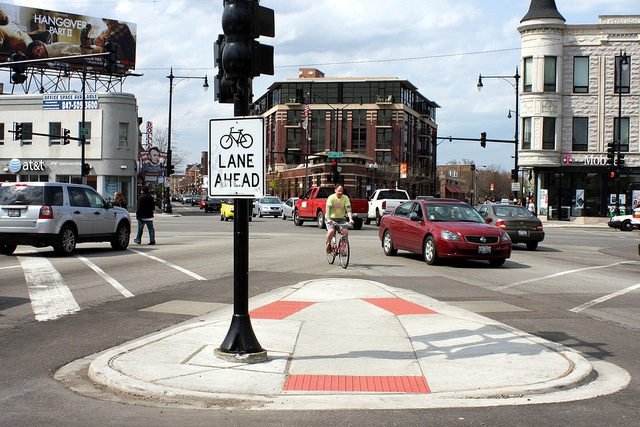Describe the objects in this image and their specific colors. I can see car in lavender, black, gray, and darkgray tones, car in lavender, black, darkgray, gray, and maroon tones, car in lavender, black, maroon, gray, and brown tones, traffic light in lavender, black, lightgray, and gray tones, and car in lavender, black, gray, and darkgray tones in this image. 